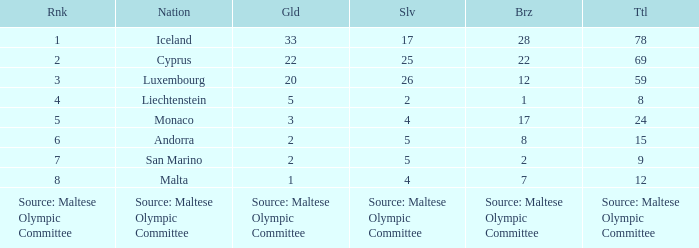How many bronze medals are owned by the number 1 ranked nation? 28.0. 